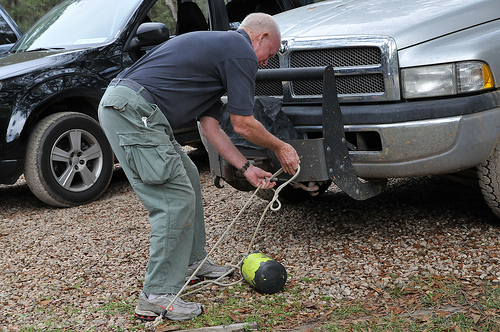What is the color of the trousers that he is wearing? His trousers are gray, practical for manual tasks and outdoor activities. 